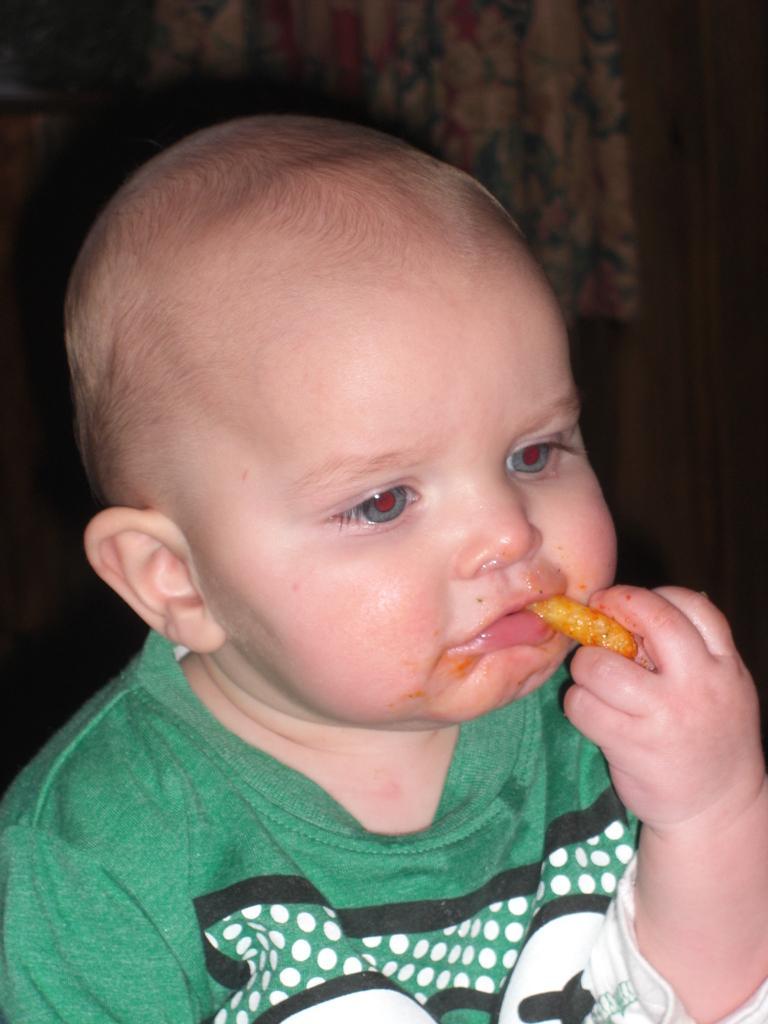Describe this image in one or two sentences. There is a kid wearing green dress is holding and eating an edible which is in his hand. 